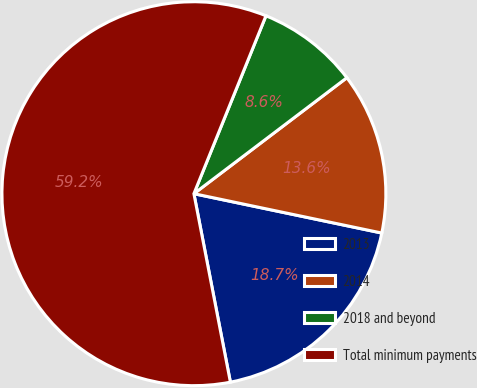Convert chart. <chart><loc_0><loc_0><loc_500><loc_500><pie_chart><fcel>2013<fcel>2014<fcel>2018 and beyond<fcel>Total minimum payments<nl><fcel>18.67%<fcel>13.61%<fcel>8.55%<fcel>59.17%<nl></chart> 